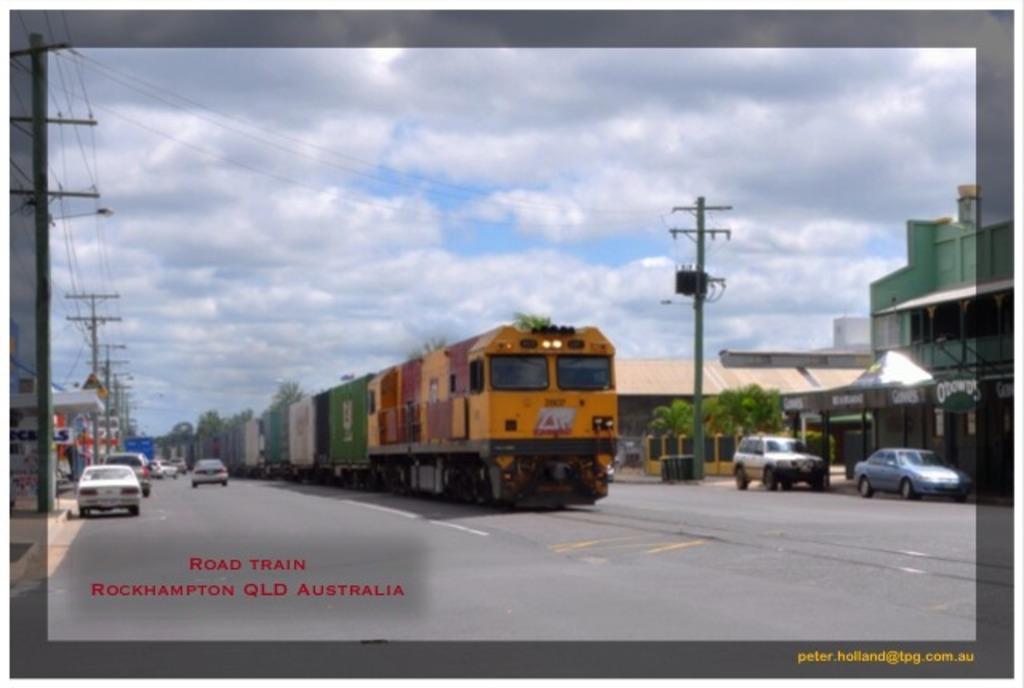How would you summarize this image in a sentence or two? In this picture there is a train on the track and there are few vehicles on either sides of it and there are few buildings and trees in the right corner and there are few stores,poles and wires in the left corner and the sky is cloudy. 